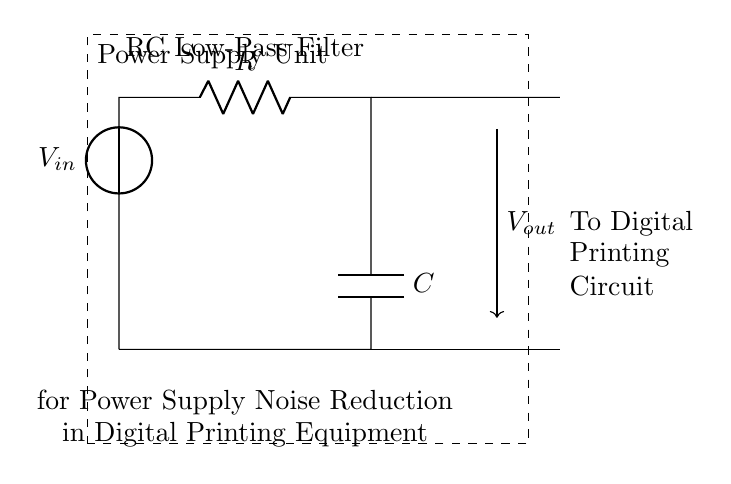What is the type of filter shown in the circuit? The circuit diagram illustrates a low-pass filter, indicated by the configuration of the resistor and capacitor, which allows low-frequency signals to pass while attenuating higher frequencies.
Answer: Low-pass filter What are the components present in the circuit? The components visible in the circuit are a resistor (R), a capacitor (C), and a voltage source (V). These are fundamental elements of the RC filter depicted in the diagram.
Answer: Resistor, Capacitor, Voltage source What is the output of the circuit labeled as? The output of the circuit is labeled as V out, which is taken from the junction between the resistor and capacitor, representing the filtered voltage signal sent to the load.
Answer: V out What is the role of the capacitor in this filter? In this low-pass filter, the capacitor acts to smooth out voltage variations, allowing low-frequency signals to pass while filtering high-frequency noise from the power supply input.
Answer: Smoothing voltage What happens to high-frequency signals in this circuit? High-frequency signals experience attenuation, meaning they are reduced in amplitude as they pass through the RC filter, making the output less noisy for the digital circuit.
Answer: Attenuated What is the purpose of this RC filter in digital printing equipment? The purpose of the RC filter is to reduce power supply noise that can interfere with digital printing operations, ensuring cleaner power is delivered to the printing circuitry.
Answer: Noise reduction What is the name of the configuration used in this type of filter? The configuration used in this circuit is known as a voltage divider consisting of a resistor and capacitor, where the output voltage is derived between these components.
Answer: Voltage divider 